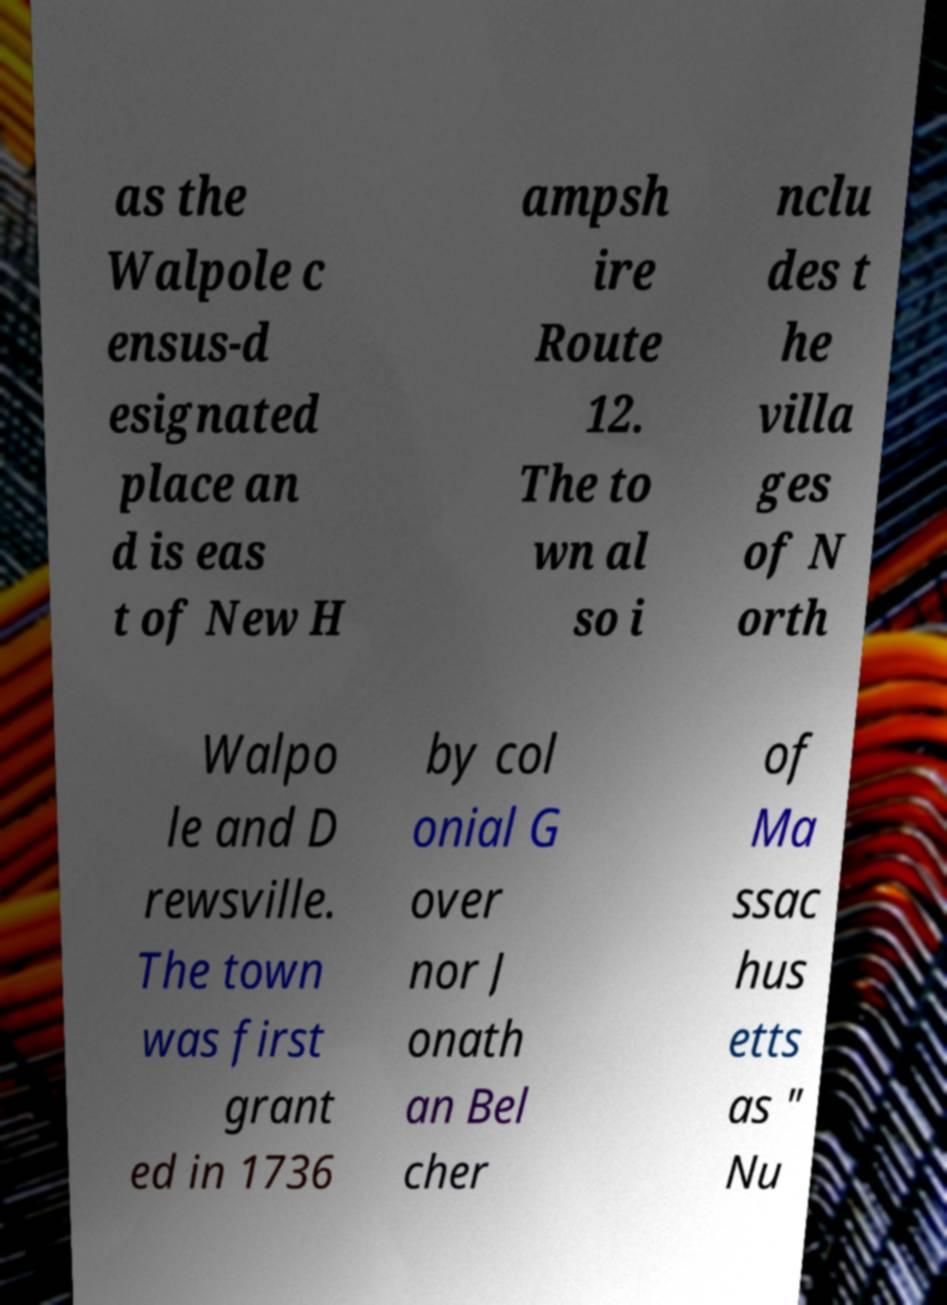What messages or text are displayed in this image? I need them in a readable, typed format. as the Walpole c ensus-d esignated place an d is eas t of New H ampsh ire Route 12. The to wn al so i nclu des t he villa ges of N orth Walpo le and D rewsville. The town was first grant ed in 1736 by col onial G over nor J onath an Bel cher of Ma ssac hus etts as " Nu 